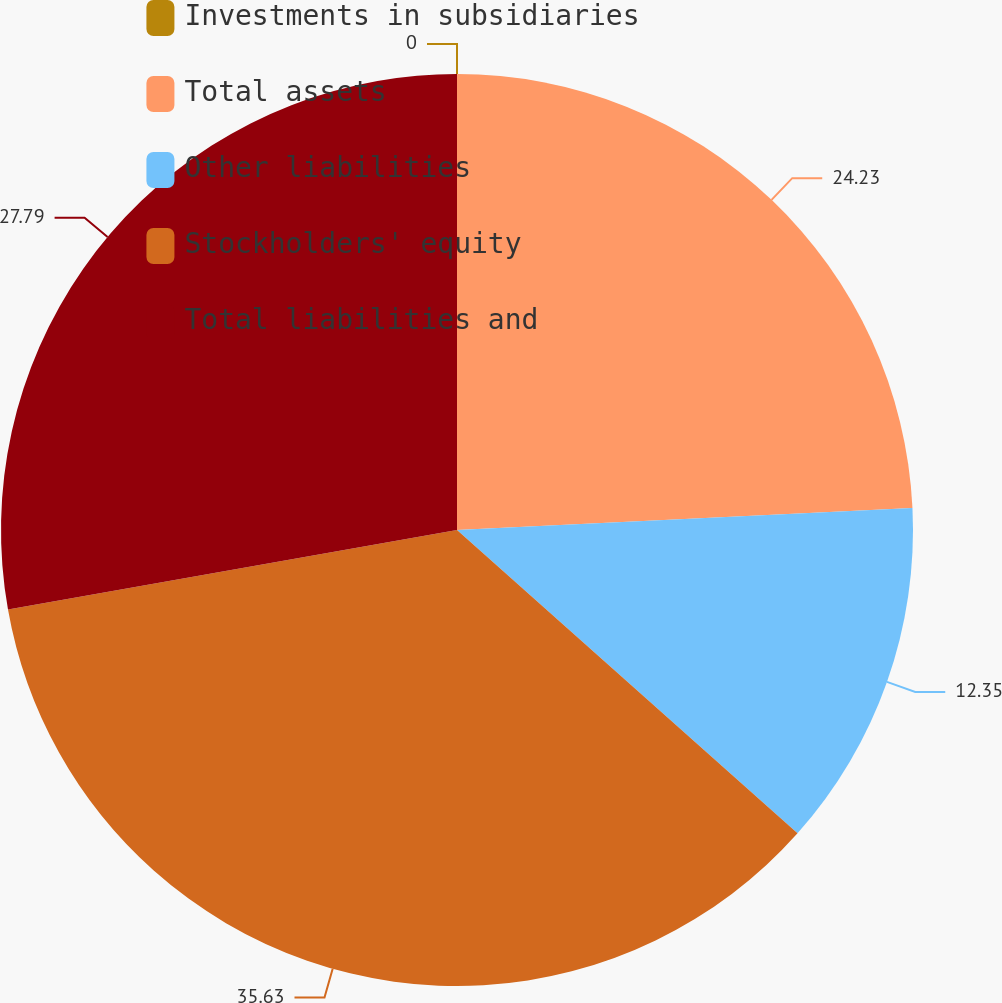Convert chart. <chart><loc_0><loc_0><loc_500><loc_500><pie_chart><fcel>Investments in subsidiaries<fcel>Total assets<fcel>Other liabilities<fcel>Stockholders' equity<fcel>Total liabilities and<nl><fcel>0.0%<fcel>24.23%<fcel>12.35%<fcel>35.63%<fcel>27.79%<nl></chart> 